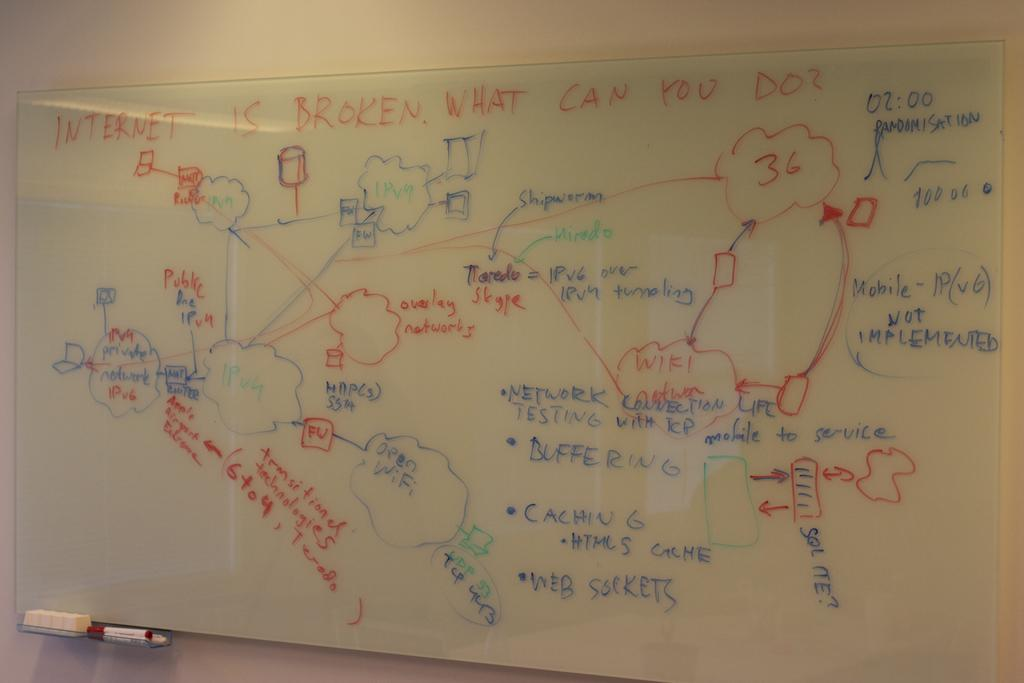<image>
Summarize the visual content of the image. The internet is broken is written in red on a white board. 